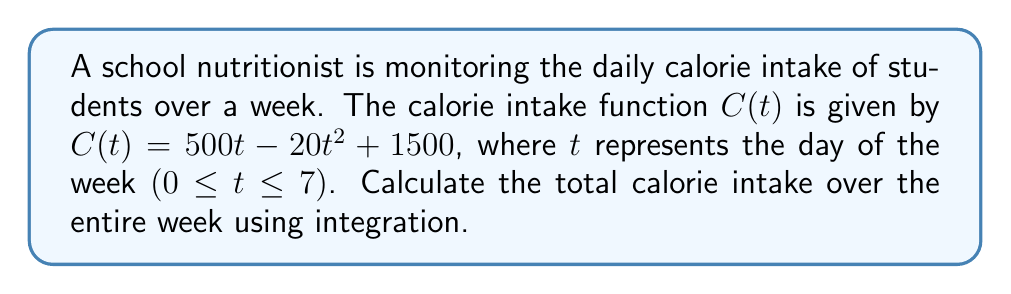Can you solve this math problem? To find the total calorie intake over the week, we need to calculate the area under the curve of $C(t)$ from $t=0$ to $t=7$. This can be done using definite integration.

Step 1: Set up the definite integral
$$\int_{0}^{7} (500t - 20t^2 + 1500) dt$$

Step 2: Integrate each term
- $\int 500t \,dt = 250t^2 + C$
- $\int -20t^2 \,dt = -\frac{20}{3}t^3 + C$
- $\int 1500 \,dt = 1500t + C$

Step 3: Apply the fundamental theorem of calculus
$$\left[ 250t^2 - \frac{20}{3}t^3 + 1500t \right]_{0}^{7}$$

Step 4: Evaluate the expression at $t=7$ and $t=0$
At $t=7$: $250(7^2) - \frac{20}{3}(7^3) + 1500(7) = 12250 - 2286.67 + 10500 = 20463.33$
At $t=0$: $250(0^2) - \frac{20}{3}(0^3) + 1500(0) = 0$

Step 5: Subtract the values
$20463.33 - 0 = 20463.33$

Therefore, the total calorie intake over the week is approximately 20,463 calories.
Answer: 20,463 calories 